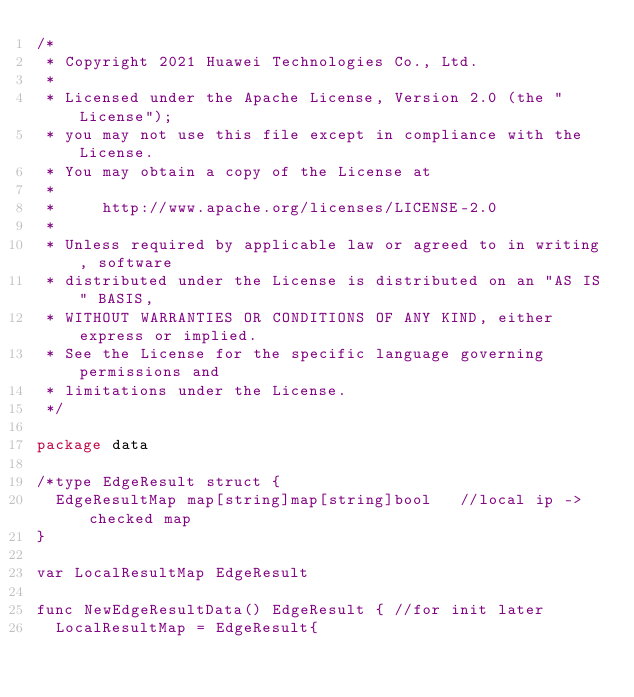<code> <loc_0><loc_0><loc_500><loc_500><_Go_>/*
 * Copyright 2021 Huawei Technologies Co., Ltd.
 *
 * Licensed under the Apache License, Version 2.0 (the "License");
 * you may not use this file except in compliance with the License.
 * You may obtain a copy of the License at
 *
 *     http://www.apache.org/licenses/LICENSE-2.0
 *
 * Unless required by applicable law or agreed to in writing, software
 * distributed under the License is distributed on an "AS IS" BASIS,
 * WITHOUT WARRANTIES OR CONDITIONS OF ANY KIND, either express or implied.
 * See the License for the specific language governing permissions and
 * limitations under the License.
 */

package data

/*type EdgeResult struct {
	EdgeResultMap map[string]map[string]bool   //local ip -> checked map
}

var LocalResultMap EdgeResult

func NewEdgeResultData() EdgeResult { //for init later
	LocalResultMap = EdgeResult{</code> 